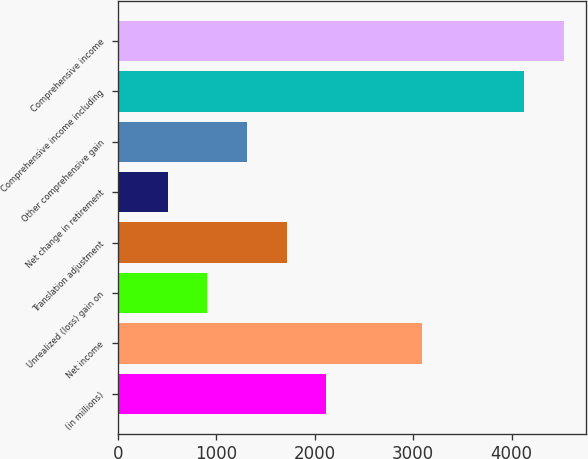<chart> <loc_0><loc_0><loc_500><loc_500><bar_chart><fcel>(in millions)<fcel>Net income<fcel>Unrealized (loss) gain on<fcel>Translation adjustment<fcel>Net change in retirement<fcel>Other comprehensive gain<fcel>Comprehensive income including<fcel>Comprehensive income<nl><fcel>2118.5<fcel>3095<fcel>909.2<fcel>1715.4<fcel>506.1<fcel>1312.3<fcel>4125<fcel>4528.1<nl></chart> 